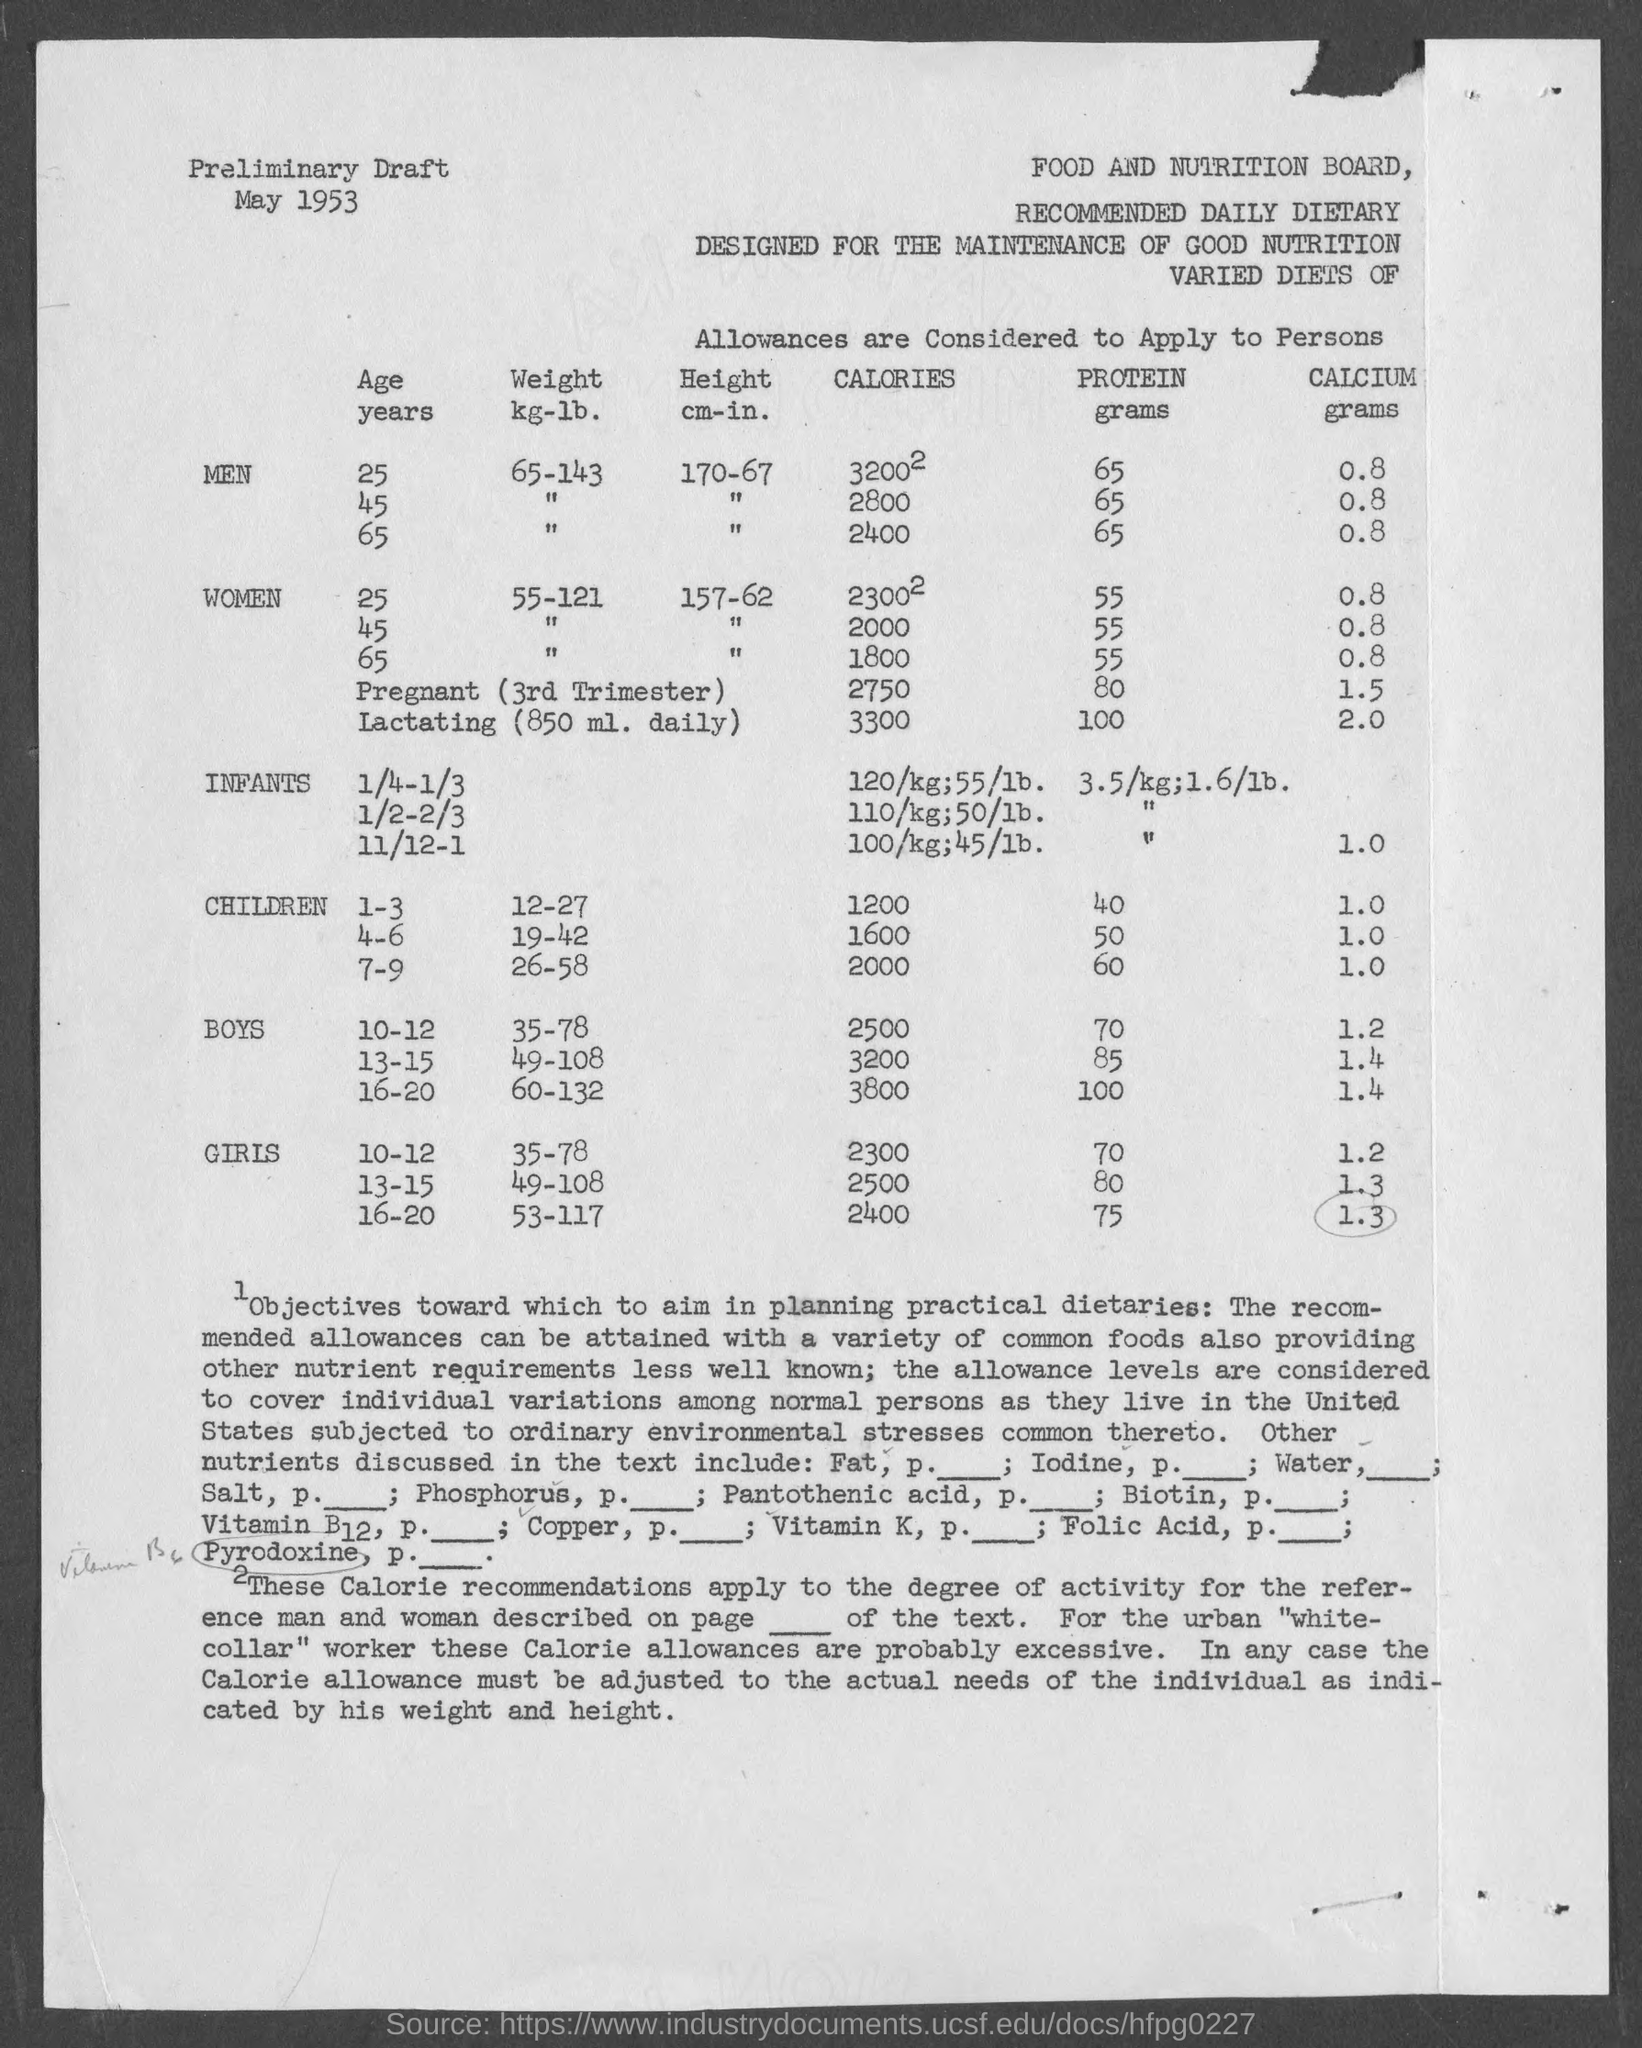What is the name of the board mentioned in the given page ?
Give a very brief answer. Food and nutrition board. What is the date mentioned in the given page ?
Your answer should be very brief. May 1953. What is  the weight kg-lb. for the men of the age 25 years ?
Ensure brevity in your answer.  65-143. What is the height cm-in. for the men of the age 25 years ?
Give a very brief answer. 170-67. What is the height cm-in. for the women of the age 25 years ?
Make the answer very short. 157-62. What is the amount of protein (grams) for men at the age of 25 years ?
Keep it short and to the point. 65. 